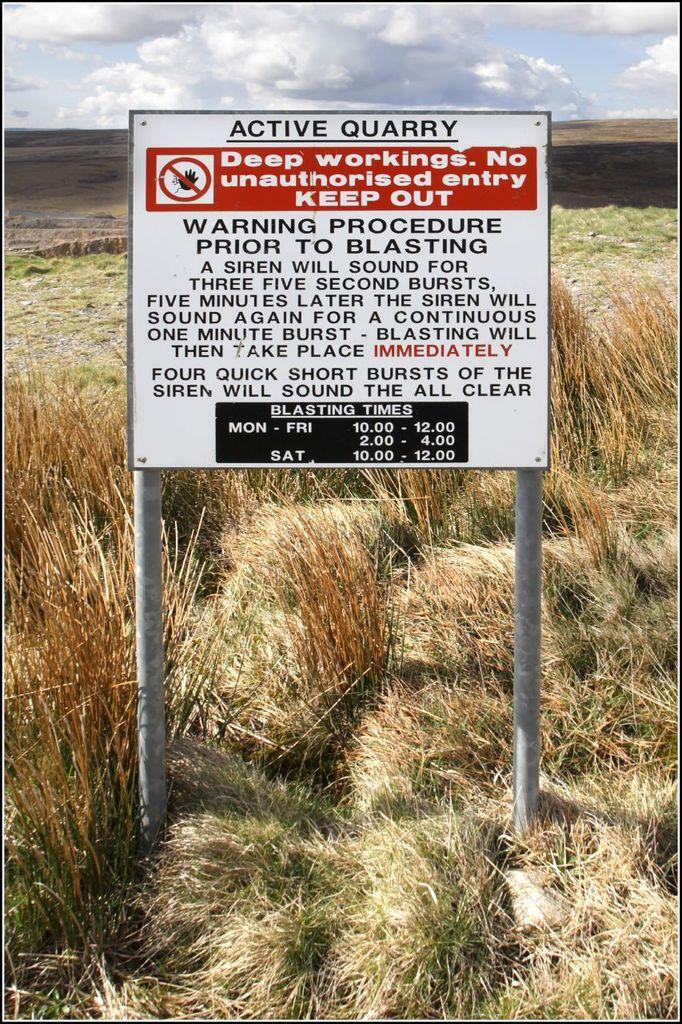What is the main object in the image? There is a board with poles in the image. What is written or displayed on the board? There is text on the board. What type of surface is under the board? There is grass on the ground. What can be seen in the background of the image? The sky is visible in the background, and there are clouds in the sky. What type of calculator is being used by the person in the image? There is no person or calculator present in the image. What hobbies are being pursued by the individuals in the image? There are no individuals or hobbies mentioned in the image. 